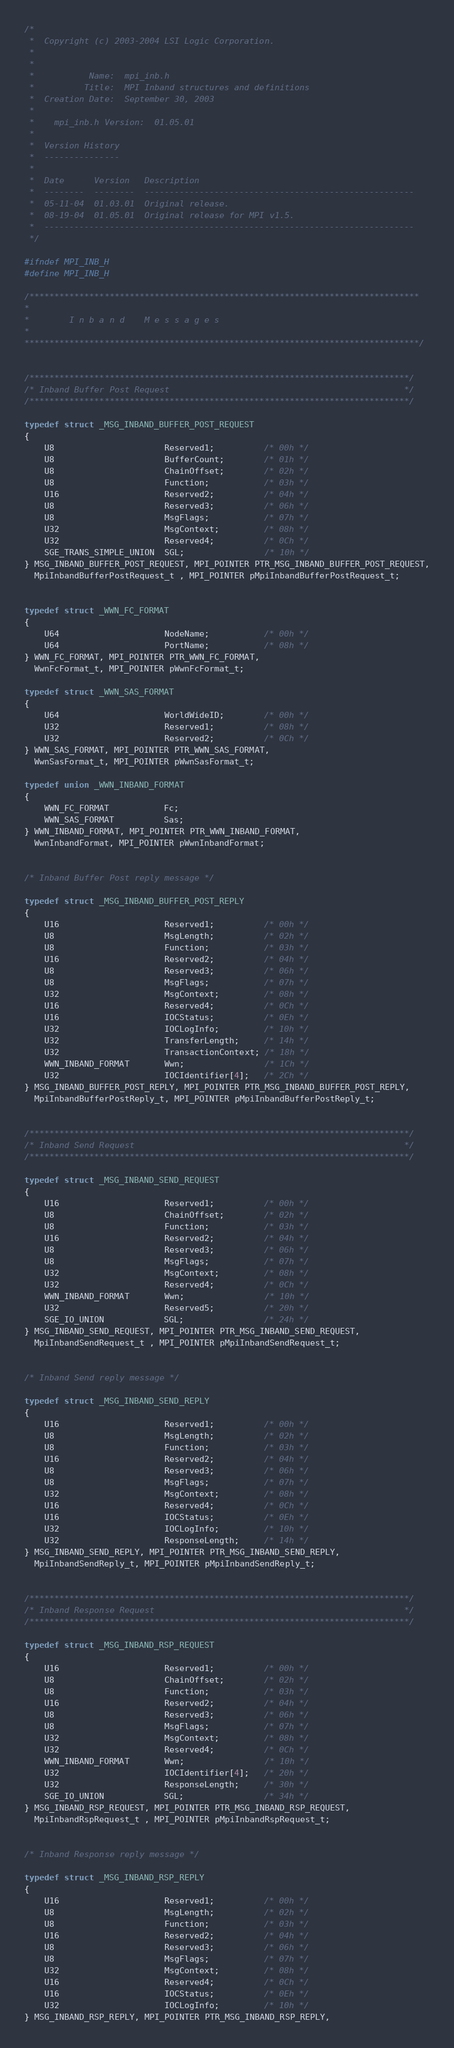<code> <loc_0><loc_0><loc_500><loc_500><_C_>/*
 *  Copyright (c) 2003-2004 LSI Logic Corporation.
 *
 *
 *           Name:  mpi_inb.h
 *          Title:  MPI Inband structures and definitions
 *  Creation Date:  September 30, 2003
 *
 *    mpi_inb.h Version:  01.05.01
 *
 *  Version History
 *  ---------------
 *
 *  Date      Version   Description
 *  --------  --------  ------------------------------------------------------
 *  05-11-04  01.03.01  Original release.
 *  08-19-04  01.05.01  Original release for MPI v1.5.
 *  --------------------------------------------------------------------------
 */

#ifndef MPI_INB_H
#define MPI_INB_H

/******************************************************************************
*
*        I n b a n d    M e s s a g e s
*
*******************************************************************************/


/****************************************************************************/
/* Inband Buffer Post Request                                               */
/****************************************************************************/

typedef struct _MSG_INBAND_BUFFER_POST_REQUEST
{
    U8                      Reserved1;          /* 00h */
    U8                      BufferCount;        /* 01h */
    U8                      ChainOffset;        /* 02h */
    U8                      Function;           /* 03h */
    U16                     Reserved2;          /* 04h */
    U8                      Reserved3;          /* 06h */
    U8                      MsgFlags;           /* 07h */
    U32                     MsgContext;         /* 08h */
    U32                     Reserved4;          /* 0Ch */
    SGE_TRANS_SIMPLE_UNION  SGL;                /* 10h */
} MSG_INBAND_BUFFER_POST_REQUEST, MPI_POINTER PTR_MSG_INBAND_BUFFER_POST_REQUEST,
  MpiInbandBufferPostRequest_t , MPI_POINTER pMpiInbandBufferPostRequest_t;


typedef struct _WWN_FC_FORMAT
{
    U64                     NodeName;           /* 00h */
    U64                     PortName;           /* 08h */
} WWN_FC_FORMAT, MPI_POINTER PTR_WWN_FC_FORMAT,
  WwnFcFormat_t, MPI_POINTER pWwnFcFormat_t;

typedef struct _WWN_SAS_FORMAT
{
    U64                     WorldWideID;        /* 00h */
    U32                     Reserved1;          /* 08h */
    U32                     Reserved2;          /* 0Ch */
} WWN_SAS_FORMAT, MPI_POINTER PTR_WWN_SAS_FORMAT,
  WwnSasFormat_t, MPI_POINTER pWwnSasFormat_t;

typedef union _WWN_INBAND_FORMAT
{
    WWN_FC_FORMAT           Fc;
    WWN_SAS_FORMAT          Sas;
} WWN_INBAND_FORMAT, MPI_POINTER PTR_WWN_INBAND_FORMAT,
  WwnInbandFormat, MPI_POINTER pWwnInbandFormat;


/* Inband Buffer Post reply message */

typedef struct _MSG_INBAND_BUFFER_POST_REPLY
{
    U16                     Reserved1;          /* 00h */
    U8                      MsgLength;          /* 02h */
    U8                      Function;           /* 03h */
    U16                     Reserved2;          /* 04h */
    U8                      Reserved3;          /* 06h */
    U8                      MsgFlags;           /* 07h */
    U32                     MsgContext;         /* 08h */
    U16                     Reserved4;          /* 0Ch */
    U16                     IOCStatus;          /* 0Eh */
    U32                     IOCLogInfo;         /* 10h */
    U32                     TransferLength;     /* 14h */
    U32                     TransactionContext; /* 18h */
    WWN_INBAND_FORMAT       Wwn;                /* 1Ch */
    U32                     IOCIdentifier[4];   /* 2Ch */
} MSG_INBAND_BUFFER_POST_REPLY, MPI_POINTER PTR_MSG_INBAND_BUFFER_POST_REPLY,
  MpiInbandBufferPostReply_t, MPI_POINTER pMpiInbandBufferPostReply_t;


/****************************************************************************/
/* Inband Send Request                                                      */
/****************************************************************************/

typedef struct _MSG_INBAND_SEND_REQUEST
{
    U16                     Reserved1;          /* 00h */
    U8                      ChainOffset;        /* 02h */
    U8                      Function;           /* 03h */
    U16                     Reserved2;          /* 04h */
    U8                      Reserved3;          /* 06h */
    U8                      MsgFlags;           /* 07h */
    U32                     MsgContext;         /* 08h */
    U32                     Reserved4;          /* 0Ch */
    WWN_INBAND_FORMAT       Wwn;                /* 10h */
    U32                     Reserved5;          /* 20h */
    SGE_IO_UNION            SGL;                /* 24h */
} MSG_INBAND_SEND_REQUEST, MPI_POINTER PTR_MSG_INBAND_SEND_REQUEST,
  MpiInbandSendRequest_t , MPI_POINTER pMpiInbandSendRequest_t;


/* Inband Send reply message */

typedef struct _MSG_INBAND_SEND_REPLY
{
    U16                     Reserved1;          /* 00h */
    U8                      MsgLength;          /* 02h */
    U8                      Function;           /* 03h */
    U16                     Reserved2;          /* 04h */
    U8                      Reserved3;          /* 06h */
    U8                      MsgFlags;           /* 07h */
    U32                     MsgContext;         /* 08h */
    U16                     Reserved4;          /* 0Ch */
    U16                     IOCStatus;          /* 0Eh */
    U32                     IOCLogInfo;         /* 10h */
    U32                     ResponseLength;     /* 14h */
} MSG_INBAND_SEND_REPLY, MPI_POINTER PTR_MSG_INBAND_SEND_REPLY,
  MpiInbandSendReply_t, MPI_POINTER pMpiInbandSendReply_t;


/****************************************************************************/
/* Inband Response Request                                                  */
/****************************************************************************/

typedef struct _MSG_INBAND_RSP_REQUEST
{
    U16                     Reserved1;          /* 00h */
    U8                      ChainOffset;        /* 02h */
    U8                      Function;           /* 03h */
    U16                     Reserved2;          /* 04h */
    U8                      Reserved3;          /* 06h */
    U8                      MsgFlags;           /* 07h */
    U32                     MsgContext;         /* 08h */
    U32                     Reserved4;          /* 0Ch */
    WWN_INBAND_FORMAT       Wwn;                /* 10h */
    U32                     IOCIdentifier[4];   /* 20h */
    U32                     ResponseLength;     /* 30h */
    SGE_IO_UNION            SGL;                /* 34h */
} MSG_INBAND_RSP_REQUEST, MPI_POINTER PTR_MSG_INBAND_RSP_REQUEST,
  MpiInbandRspRequest_t , MPI_POINTER pMpiInbandRspRequest_t;


/* Inband Response reply message */

typedef struct _MSG_INBAND_RSP_REPLY
{
    U16                     Reserved1;          /* 00h */
    U8                      MsgLength;          /* 02h */
    U8                      Function;           /* 03h */
    U16                     Reserved2;          /* 04h */
    U8                      Reserved3;          /* 06h */
    U8                      MsgFlags;           /* 07h */
    U32                     MsgContext;         /* 08h */
    U16                     Reserved4;          /* 0Ch */
    U16                     IOCStatus;          /* 0Eh */
    U32                     IOCLogInfo;         /* 10h */
} MSG_INBAND_RSP_REPLY, MPI_POINTER PTR_MSG_INBAND_RSP_REPLY,</code> 